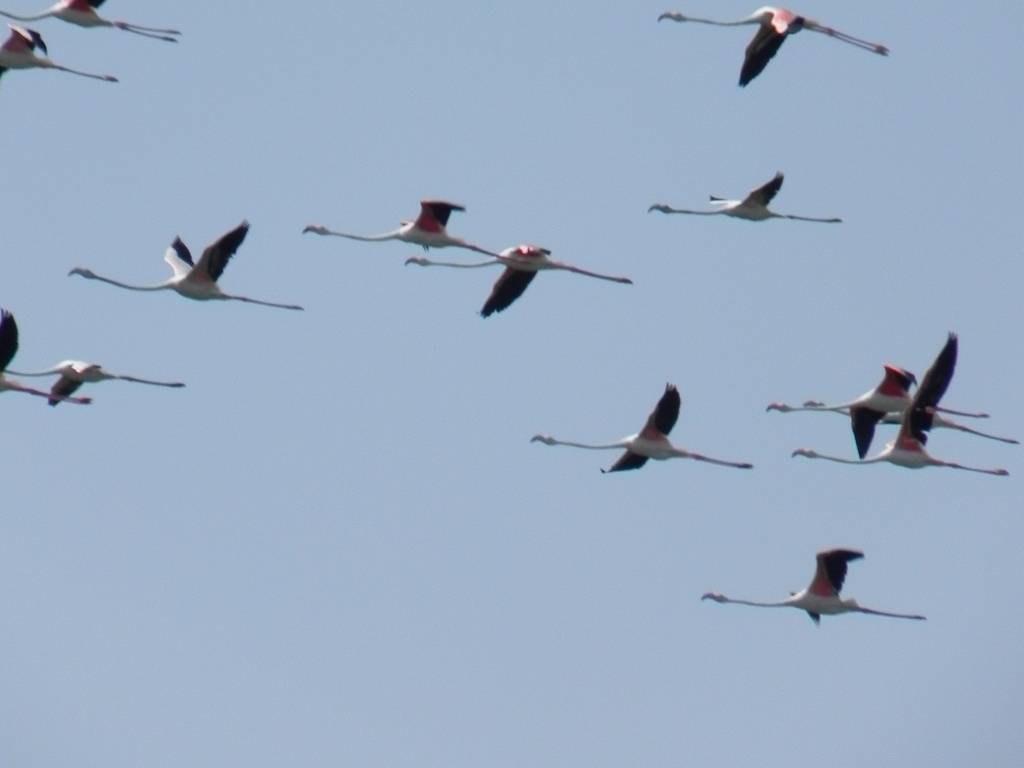What species of birds are these, and can you provide some interesting facts about them? These appear to be flamingos in flight, characterized by their long necks, stick-like legs, and distinctive pink and black wing coloring. An interesting fact about flamingos is that their pink color comes from the food they eat, which is rich in carotenoids. Also, flamingos are social birds that perform synchronized group movements and rituals to strengthen their social bonds. 